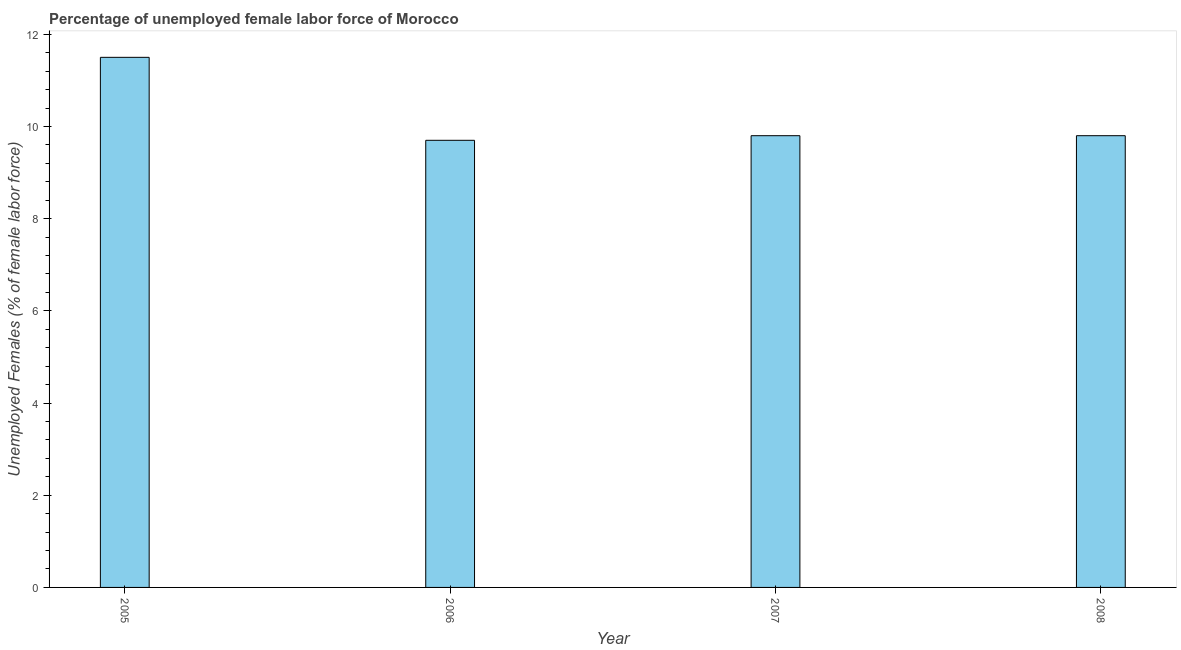Does the graph contain any zero values?
Provide a short and direct response. No. Does the graph contain grids?
Offer a terse response. No. What is the title of the graph?
Keep it short and to the point. Percentage of unemployed female labor force of Morocco. What is the label or title of the X-axis?
Give a very brief answer. Year. What is the label or title of the Y-axis?
Offer a terse response. Unemployed Females (% of female labor force). What is the total unemployed female labour force in 2006?
Offer a very short reply. 9.7. Across all years, what is the maximum total unemployed female labour force?
Give a very brief answer. 11.5. Across all years, what is the minimum total unemployed female labour force?
Your response must be concise. 9.7. In which year was the total unemployed female labour force maximum?
Offer a terse response. 2005. What is the sum of the total unemployed female labour force?
Your response must be concise. 40.8. What is the difference between the total unemployed female labour force in 2005 and 2008?
Ensure brevity in your answer.  1.7. What is the median total unemployed female labour force?
Make the answer very short. 9.8. In how many years, is the total unemployed female labour force greater than 0.8 %?
Provide a succinct answer. 4. What is the ratio of the total unemployed female labour force in 2005 to that in 2007?
Ensure brevity in your answer.  1.17. Is the difference between the total unemployed female labour force in 2006 and 2008 greater than the difference between any two years?
Make the answer very short. No. What is the difference between the highest and the second highest total unemployed female labour force?
Make the answer very short. 1.7. How many years are there in the graph?
Give a very brief answer. 4. What is the difference between two consecutive major ticks on the Y-axis?
Offer a terse response. 2. What is the Unemployed Females (% of female labor force) of 2006?
Provide a short and direct response. 9.7. What is the Unemployed Females (% of female labor force) in 2007?
Provide a succinct answer. 9.8. What is the Unemployed Females (% of female labor force) of 2008?
Your answer should be very brief. 9.8. What is the difference between the Unemployed Females (% of female labor force) in 2005 and 2006?
Provide a succinct answer. 1.8. What is the difference between the Unemployed Females (% of female labor force) in 2006 and 2007?
Your answer should be very brief. -0.1. What is the ratio of the Unemployed Females (% of female labor force) in 2005 to that in 2006?
Offer a very short reply. 1.19. What is the ratio of the Unemployed Females (% of female labor force) in 2005 to that in 2007?
Offer a terse response. 1.17. What is the ratio of the Unemployed Females (% of female labor force) in 2005 to that in 2008?
Provide a short and direct response. 1.17. What is the ratio of the Unemployed Females (% of female labor force) in 2006 to that in 2007?
Your answer should be compact. 0.99. 